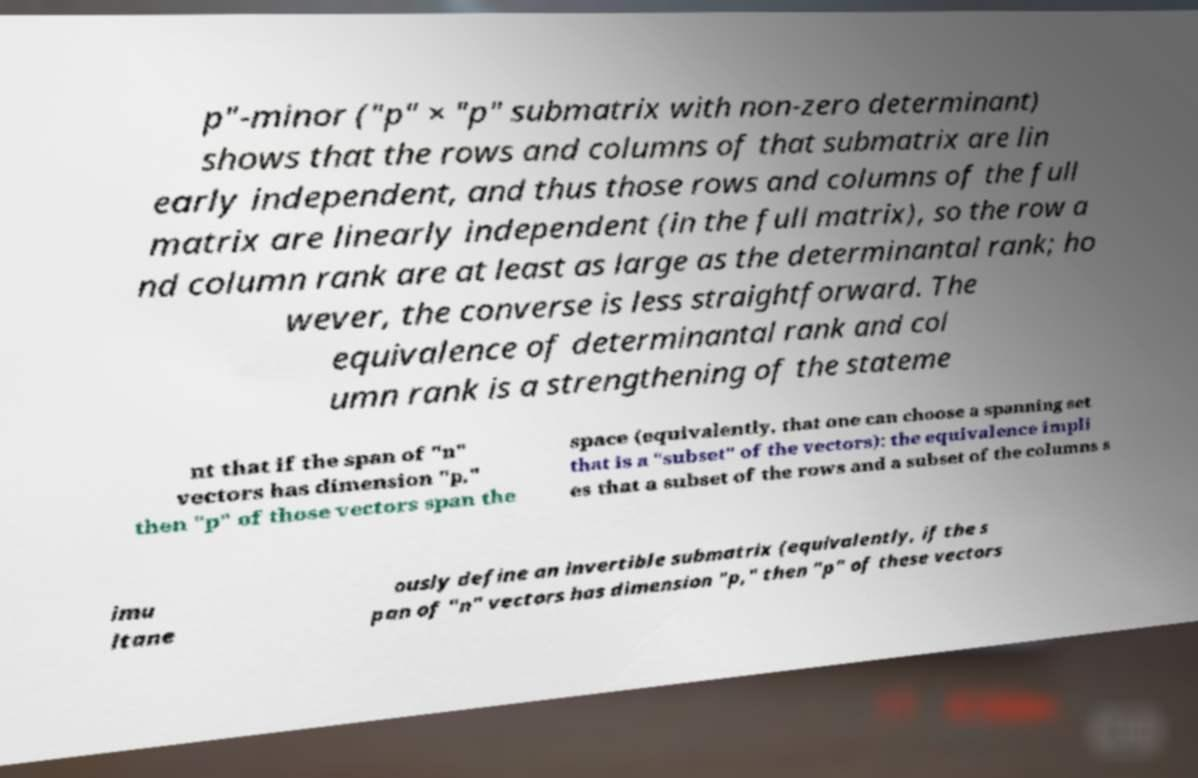For documentation purposes, I need the text within this image transcribed. Could you provide that? p"-minor ("p" × "p" submatrix with non-zero determinant) shows that the rows and columns of that submatrix are lin early independent, and thus those rows and columns of the full matrix are linearly independent (in the full matrix), so the row a nd column rank are at least as large as the determinantal rank; ho wever, the converse is less straightforward. The equivalence of determinantal rank and col umn rank is a strengthening of the stateme nt that if the span of "n" vectors has dimension "p," then "p" of those vectors span the space (equivalently, that one can choose a spanning set that is a "subset" of the vectors): the equivalence impli es that a subset of the rows and a subset of the columns s imu ltane ously define an invertible submatrix (equivalently, if the s pan of "n" vectors has dimension "p," then "p" of these vectors 